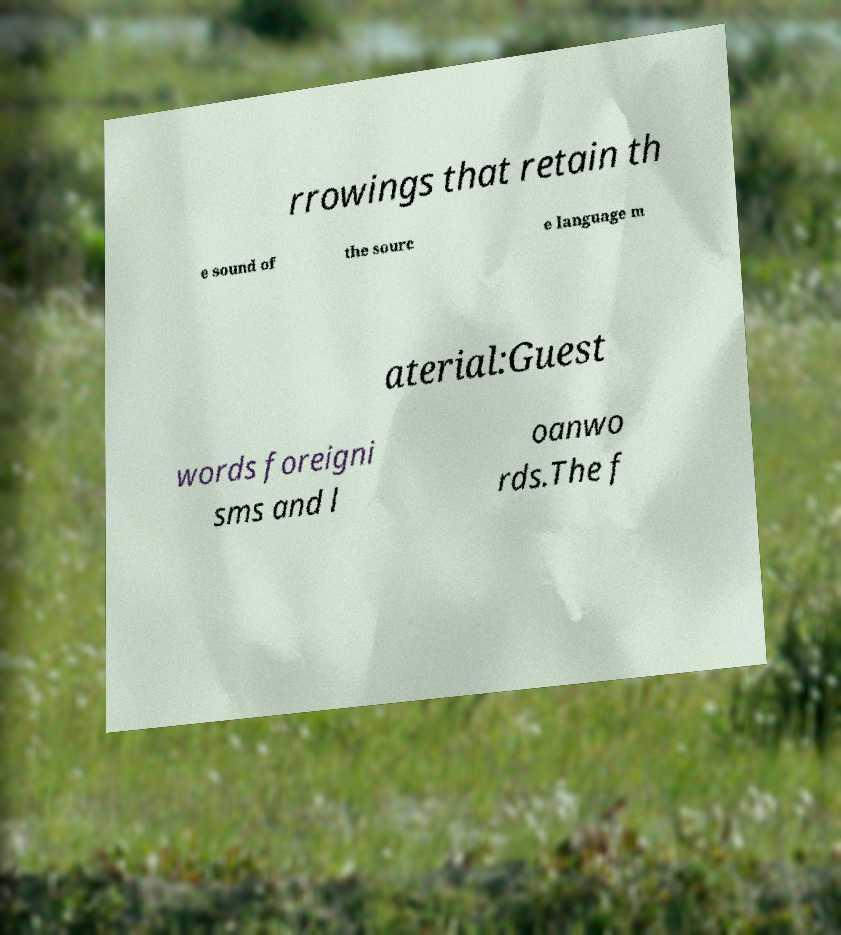I need the written content from this picture converted into text. Can you do that? rrowings that retain th e sound of the sourc e language m aterial:Guest words foreigni sms and l oanwo rds.The f 